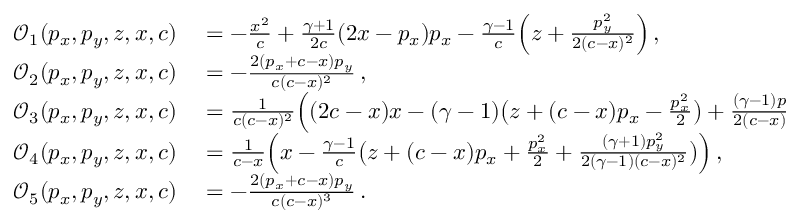<formula> <loc_0><loc_0><loc_500><loc_500>\begin{array} { r l } { \mathcal { O } _ { 1 } ( p _ { x } , p _ { y } , z , x , c ) } & = - \frac { x ^ { 2 } } { c } + \frac { \gamma + 1 } { 2 c } ( 2 x - p _ { x } ) p _ { x } - \frac { \gamma - 1 } { c } \left ( z + \frac { p _ { y } ^ { 2 } } { 2 ( c - x ) ^ { 2 } } \right ) \, , } \\ { \mathcal { O } _ { 2 } ( p _ { x } , p _ { y } , z , x , c ) } & = - \frac { 2 ( p _ { x } + c - x ) p _ { y } } { c ( c - x ) ^ { 2 } } \, , } \\ { \mathcal { O } _ { 3 } ( p _ { x } , p _ { y } , z , x , c ) } & = \frac { 1 } { c ( c - x ) ^ { 2 } } \left ( ( 2 c - x ) x - ( \gamma - 1 ) \left ( z + ( c - x ) p _ { x } - \frac { p _ { x } ^ { 2 } } { 2 } \right ) + \frac { ( \gamma - 1 ) p _ { y } ^ { 2 } } { 2 ( c - x ) ^ { 2 } } \right ) \, , } \\ { \mathcal { O } _ { 4 } ( p _ { x } , p _ { y } , z , x , c ) } & = \frac { 1 } { c - x } \left ( x - \frac { \gamma - 1 } { c } \left ( z + ( c - x ) p _ { x } + \frac { p _ { x } ^ { 2 } } { 2 } + \frac { ( \gamma + 1 ) p _ { y } ^ { 2 } } { 2 ( \gamma - 1 ) ( c - x ) ^ { 2 } } \right ) \right ) \, , } \\ { \mathcal { O } _ { 5 } ( p _ { x } , p _ { y } , z , x , c ) } & = - \frac { 2 ( p _ { x } + c - x ) p _ { y } } { c ( c - x ) ^ { 3 } } \, . } \end{array}</formula> 